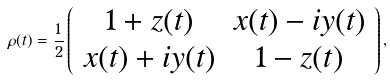<formula> <loc_0><loc_0><loc_500><loc_500>\rho ( t ) = \frac { 1 } { 2 } \left ( \begin{array} { c c } 1 + z ( t ) & x ( t ) - i y ( t ) \\ x ( t ) + i y ( t ) & 1 - z ( t ) \end{array} \right ) ,</formula> 